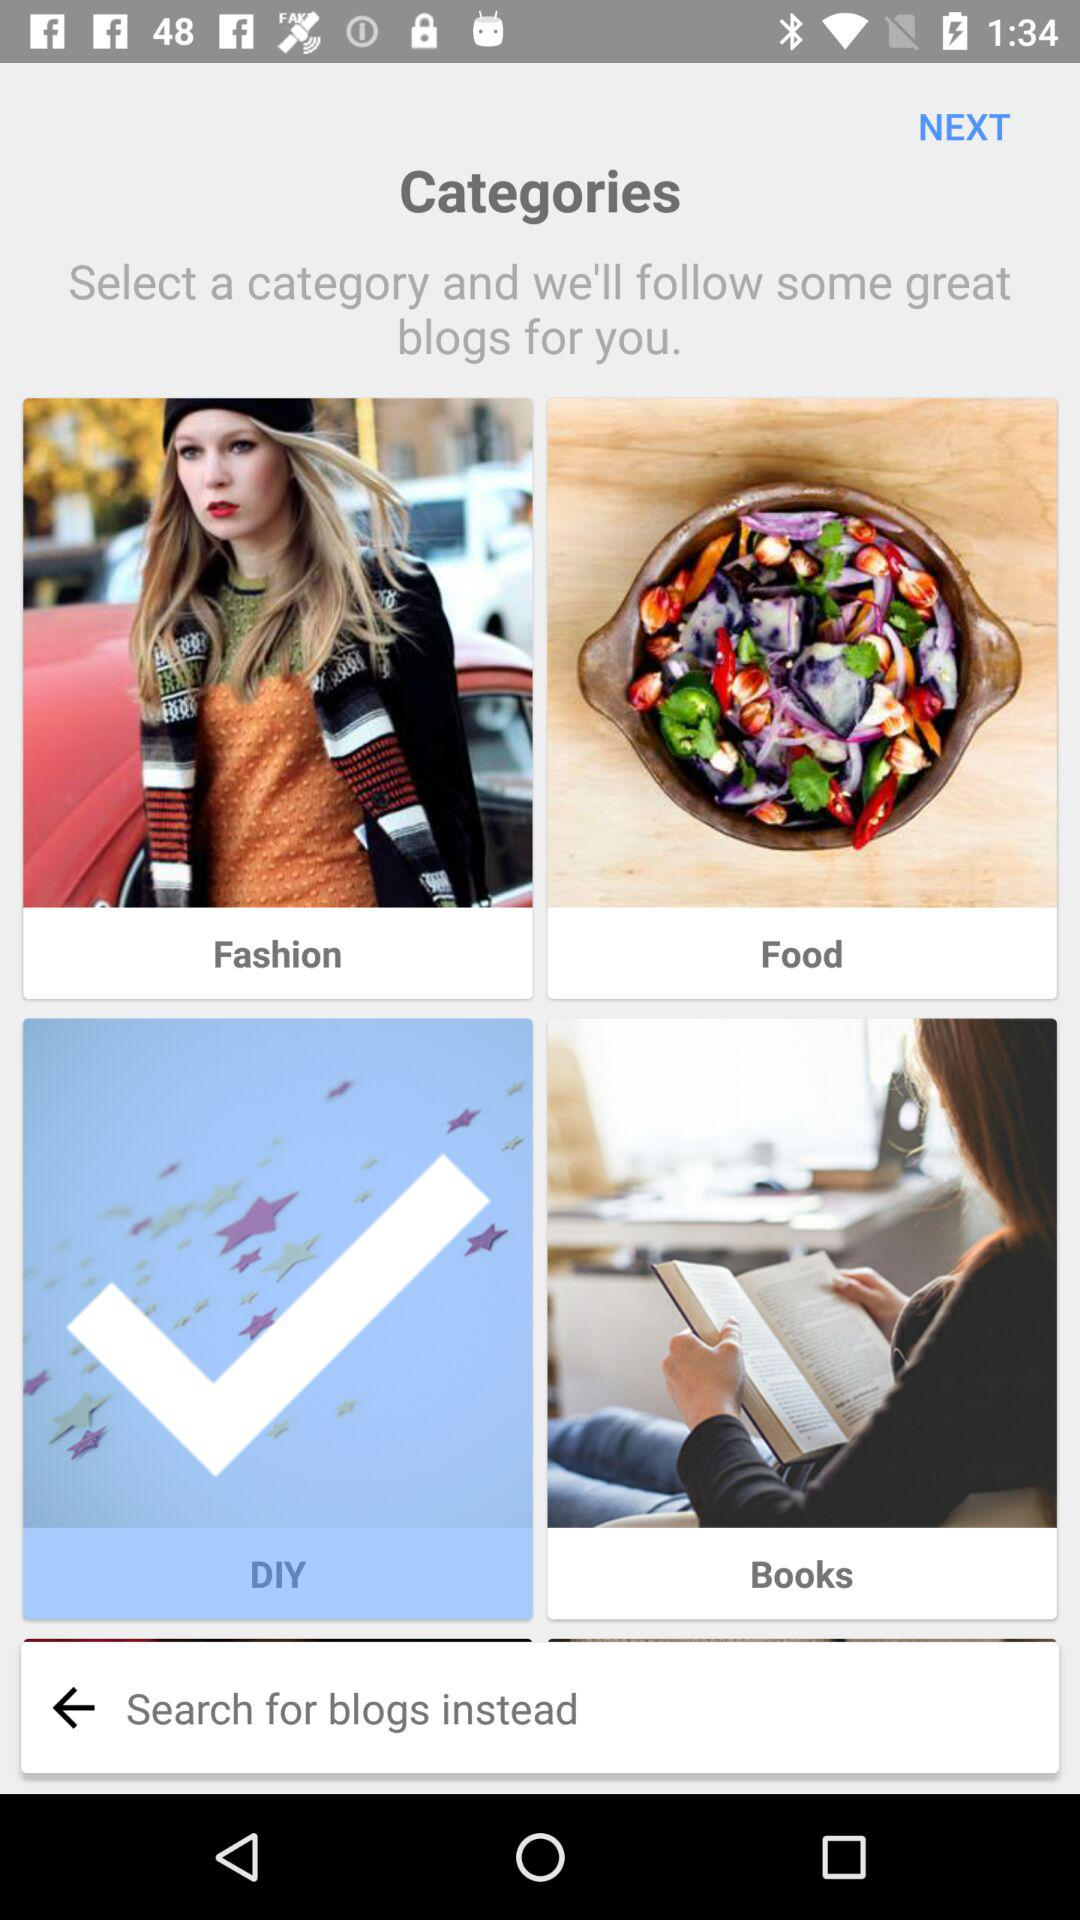Which category is selected? The selected category is "DIY". 